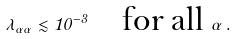Convert formula to latex. <formula><loc_0><loc_0><loc_500><loc_500>\lambda _ { \alpha \alpha } \lesssim 1 0 ^ { - 3 } \quad \text {for all } \alpha \, .</formula> 